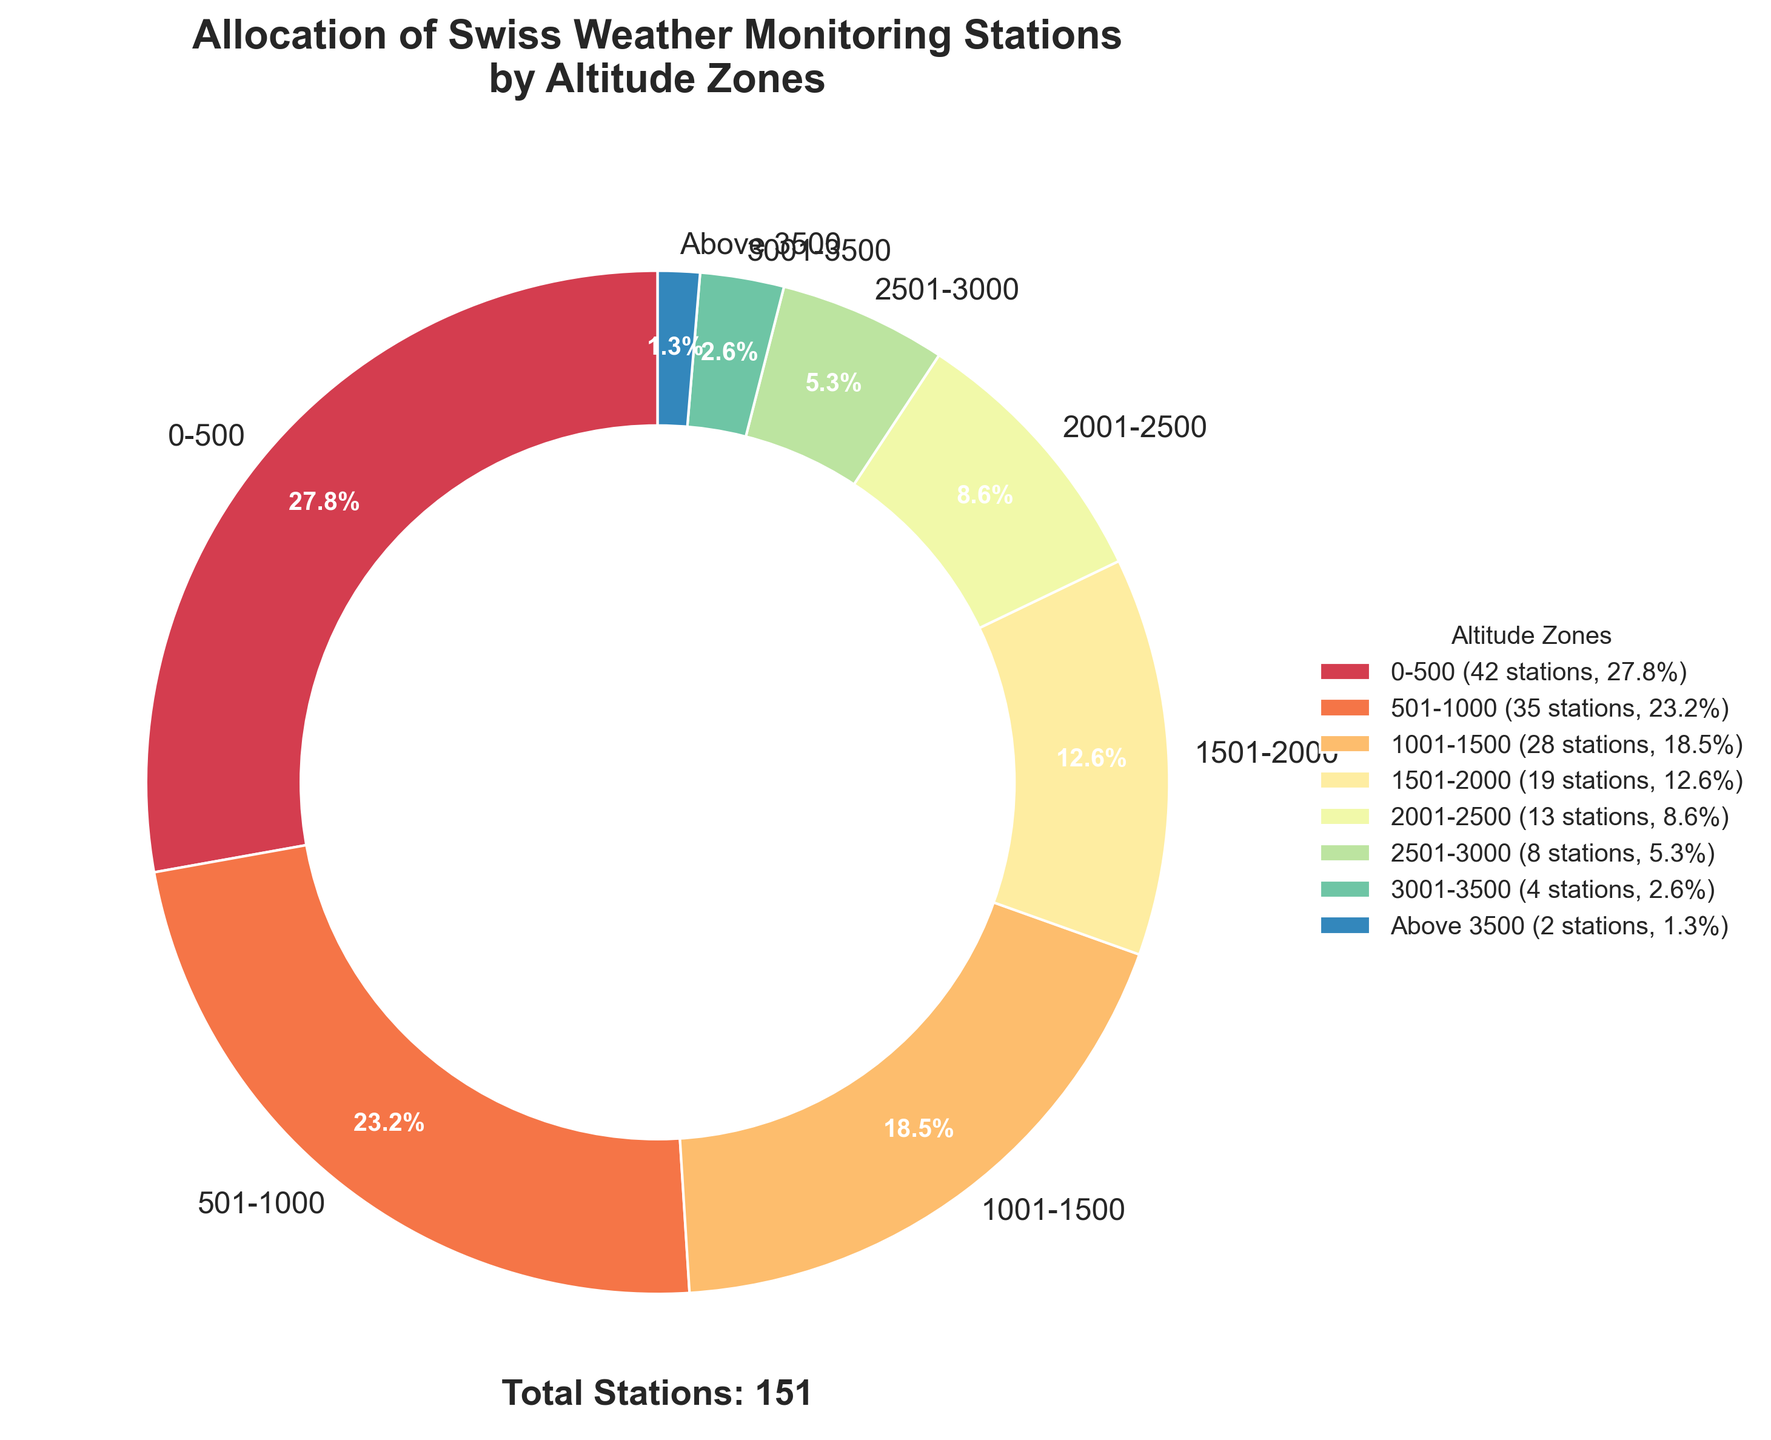What is the total number of weather monitoring stations across all altitude zones? The figure states a total number of stations at the bottom. It says "Total Stations: 151", hence that's the total number of weather monitoring stations.
Answer: 151 Which altitude zone has the highest number of weather monitoring stations? By looking at the size of the slices in the pie chart, the "0-500 m" altitude zone has the largest slice, indicating it has the highest number of stations.
Answer: 0-500 m How does the number of stations in the 1501-2000 m zone compare to the number in the 501-1000 m zone? According to the labels on the pie chart, the 1501-2000 m zone has 19 stations while the 501-1000 m zone has 35 stations. Therefore, the 501-1000 m zone has more stations.
Answer: 501-1000 m has more stations What percentage of weather monitoring stations are located at altitudes above 2000 m? To find this, sum the percentages of zones above 2000 m: 2001-2500 m: 8.6%, 2501-3000 m: 5.3%, 3001-3500 m: 2.6%, Above 3500 m: 1.3%. The total percentage is 8.6% + 5.3% + 2.6% + 1.3% = 17.8%.
Answer: 17.8% If a new weather monitoring station is added to the 1001-1500 m zone, how will this affect the total number of stations and its percentage? The new total number of stations will be 151 + 1 = 152. The number in the 1001-1500 m zone will be 28 + 1 = 29. The new percentage for this zone will be (29 / 152) * 100 ≈ 19.1%.
Answer: 152 total, 19.1% for 1001-1500 m Describe the visual representation used for the 501-1000 m altitude zone in the pie chart. In the pie chart, the 501-1000 m zone is represented by a slice that is the second largest in size. It is assigned a distinct color from the spectral color scheme and labeled clearly on the chart.
Answer: Second largest slice, distinct color For the altitude ranges with less than 10 stations, what fraction of the total stations do they represent? Zones with fewer than 10 stations are 2501-3000 m (8 stations), 3001-3500 m (4 stations), and Above 3500 m (2 stations). The total is 8 + 4 + 2 = 14 stations. The fraction of total stations is 14 / 151 = 0.093 or approximately 9.3% of the total.
Answer: 9.3% 